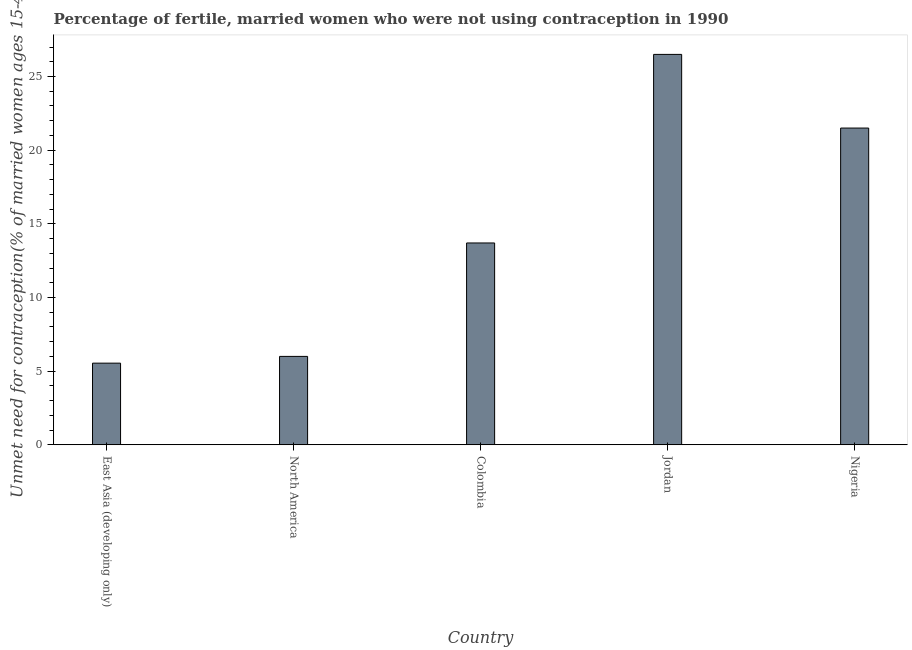Does the graph contain any zero values?
Provide a short and direct response. No. What is the title of the graph?
Your answer should be compact. Percentage of fertile, married women who were not using contraception in 1990. What is the label or title of the X-axis?
Ensure brevity in your answer.  Country. What is the label or title of the Y-axis?
Offer a terse response.  Unmet need for contraception(% of married women ages 15-49). Across all countries, what is the maximum number of married women who are not using contraception?
Your answer should be very brief. 26.5. Across all countries, what is the minimum number of married women who are not using contraception?
Ensure brevity in your answer.  5.54. In which country was the number of married women who are not using contraception maximum?
Make the answer very short. Jordan. In which country was the number of married women who are not using contraception minimum?
Your answer should be compact. East Asia (developing only). What is the sum of the number of married women who are not using contraception?
Your response must be concise. 73.24. What is the difference between the number of married women who are not using contraception in East Asia (developing only) and Nigeria?
Offer a terse response. -15.96. What is the average number of married women who are not using contraception per country?
Offer a terse response. 14.65. What is the median number of married women who are not using contraception?
Your answer should be very brief. 13.7. What is the ratio of the number of married women who are not using contraception in Colombia to that in East Asia (developing only)?
Keep it short and to the point. 2.47. Is the difference between the number of married women who are not using contraception in Colombia and Nigeria greater than the difference between any two countries?
Your answer should be very brief. No. What is the difference between the highest and the lowest number of married women who are not using contraception?
Give a very brief answer. 20.96. In how many countries, is the number of married women who are not using contraception greater than the average number of married women who are not using contraception taken over all countries?
Keep it short and to the point. 2. What is the difference between two consecutive major ticks on the Y-axis?
Provide a succinct answer. 5. Are the values on the major ticks of Y-axis written in scientific E-notation?
Your response must be concise. No. What is the  Unmet need for contraception(% of married women ages 15-49) in East Asia (developing only)?
Provide a succinct answer. 5.54. What is the  Unmet need for contraception(% of married women ages 15-49) of Colombia?
Keep it short and to the point. 13.7. What is the  Unmet need for contraception(% of married women ages 15-49) of Nigeria?
Keep it short and to the point. 21.5. What is the difference between the  Unmet need for contraception(% of married women ages 15-49) in East Asia (developing only) and North America?
Keep it short and to the point. -0.46. What is the difference between the  Unmet need for contraception(% of married women ages 15-49) in East Asia (developing only) and Colombia?
Your answer should be compact. -8.16. What is the difference between the  Unmet need for contraception(% of married women ages 15-49) in East Asia (developing only) and Jordan?
Your response must be concise. -20.96. What is the difference between the  Unmet need for contraception(% of married women ages 15-49) in East Asia (developing only) and Nigeria?
Keep it short and to the point. -15.96. What is the difference between the  Unmet need for contraception(% of married women ages 15-49) in North America and Colombia?
Your response must be concise. -7.7. What is the difference between the  Unmet need for contraception(% of married women ages 15-49) in North America and Jordan?
Offer a terse response. -20.5. What is the difference between the  Unmet need for contraception(% of married women ages 15-49) in North America and Nigeria?
Give a very brief answer. -15.5. What is the difference between the  Unmet need for contraception(% of married women ages 15-49) in Colombia and Jordan?
Offer a terse response. -12.8. What is the difference between the  Unmet need for contraception(% of married women ages 15-49) in Colombia and Nigeria?
Give a very brief answer. -7.8. What is the ratio of the  Unmet need for contraception(% of married women ages 15-49) in East Asia (developing only) to that in North America?
Make the answer very short. 0.92. What is the ratio of the  Unmet need for contraception(% of married women ages 15-49) in East Asia (developing only) to that in Colombia?
Ensure brevity in your answer.  0.41. What is the ratio of the  Unmet need for contraception(% of married women ages 15-49) in East Asia (developing only) to that in Jordan?
Provide a succinct answer. 0.21. What is the ratio of the  Unmet need for contraception(% of married women ages 15-49) in East Asia (developing only) to that in Nigeria?
Give a very brief answer. 0.26. What is the ratio of the  Unmet need for contraception(% of married women ages 15-49) in North America to that in Colombia?
Your response must be concise. 0.44. What is the ratio of the  Unmet need for contraception(% of married women ages 15-49) in North America to that in Jordan?
Provide a succinct answer. 0.23. What is the ratio of the  Unmet need for contraception(% of married women ages 15-49) in North America to that in Nigeria?
Offer a very short reply. 0.28. What is the ratio of the  Unmet need for contraception(% of married women ages 15-49) in Colombia to that in Jordan?
Keep it short and to the point. 0.52. What is the ratio of the  Unmet need for contraception(% of married women ages 15-49) in Colombia to that in Nigeria?
Keep it short and to the point. 0.64. What is the ratio of the  Unmet need for contraception(% of married women ages 15-49) in Jordan to that in Nigeria?
Keep it short and to the point. 1.23. 